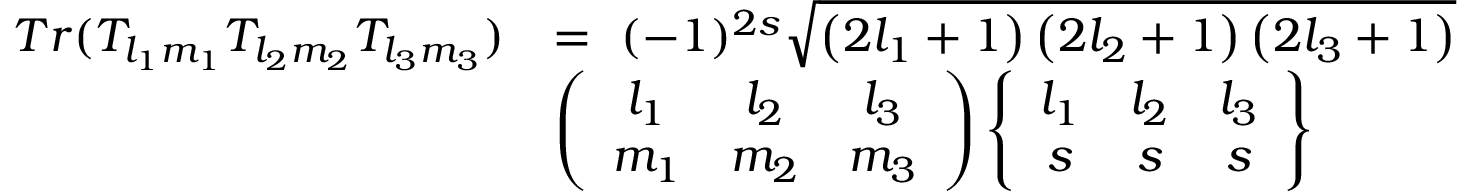Convert formula to latex. <formula><loc_0><loc_0><loc_500><loc_500>\begin{array} { r l } { T r ( T _ { l _ { 1 } m _ { 1 } } T _ { l _ { 2 } m _ { 2 } } T _ { l _ { 3 } m _ { 3 } } ) } & { = \ ( - 1 ) ^ { 2 s } \sqrt { \left ( 2 l _ { 1 } + 1 \right ) \left ( 2 l _ { 2 } + 1 \right ) \left ( 2 l _ { 3 } + 1 \right ) } } \\ & { \left ( \begin{array} { c c c } { l _ { 1 } } & { l _ { 2 } } & { l _ { 3 } } \\ { m _ { 1 } } & { m _ { 2 } } & { m _ { 3 } } \end{array} \right ) \left \{ \begin{array} { c c c } { l _ { 1 } } & { l _ { 2 } } & { l _ { 3 } } \\ { s } & { s } & { s } \end{array} \right \} } \end{array}</formula> 